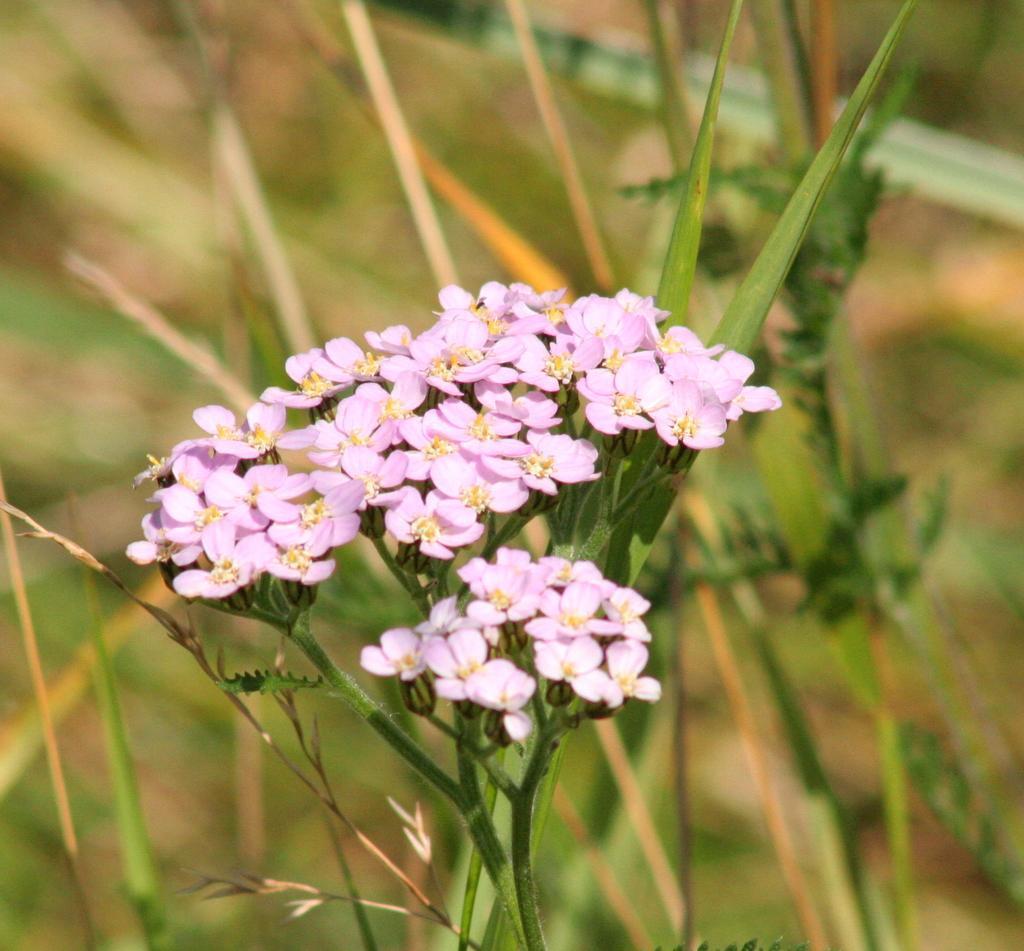Could you give a brief overview of what you see in this image? In the middle of the image we can see some flowers and plants. Background of the image is blur. 